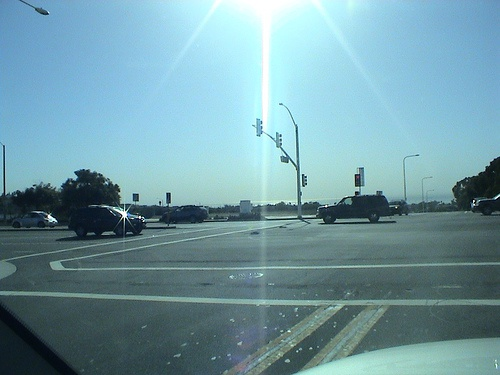Describe the objects in this image and their specific colors. I can see car in gray, black, purple, darkblue, and white tones, truck in gray, navy, darkblue, purple, and teal tones, car in gray, navy, and blue tones, car in gray, black, darkblue, and blue tones, and car in gray, black, and teal tones in this image. 